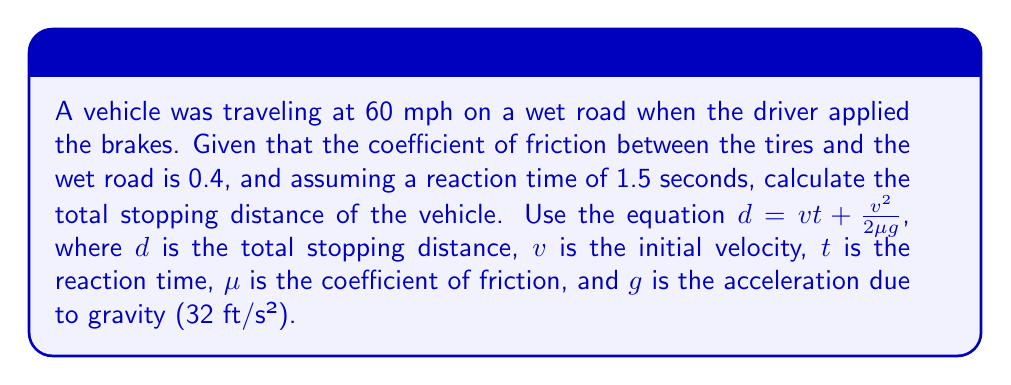Teach me how to tackle this problem. To solve this problem, we'll follow these steps:

1. Convert the initial speed from mph to ft/s:
   $60 \text{ mph} = 60 \times \frac{5280 \text{ ft}}{3600 \text{ s}} = 88 \text{ ft/s}$

2. Use the given equation: $d = v t + \frac{v^2}{2\mu g}$

3. Substitute the known values:
   $v = 88 \text{ ft/s}$
   $t = 1.5 \text{ s}$
   $\mu = 0.4$
   $g = 32 \text{ ft/s}^2$

4. Calculate the distance traveled during reaction time:
   $d_{\text{reaction}} = v t = 88 \times 1.5 = 132 \text{ ft}$

5. Calculate the braking distance:
   $d_{\text{braking}} = \frac{v^2}{2\mu g} = \frac{88^2}{2 \times 0.4 \times 32} = \frac{7744}{25.6} = 302.5 \text{ ft}$

6. Sum the reaction distance and braking distance:
   $d_{\text{total}} = d_{\text{reaction}} + d_{\text{braking}} = 132 + 302.5 = 434.5 \text{ ft}$

Therefore, the total stopping distance is approximately 434.5 feet.
Answer: 434.5 ft 